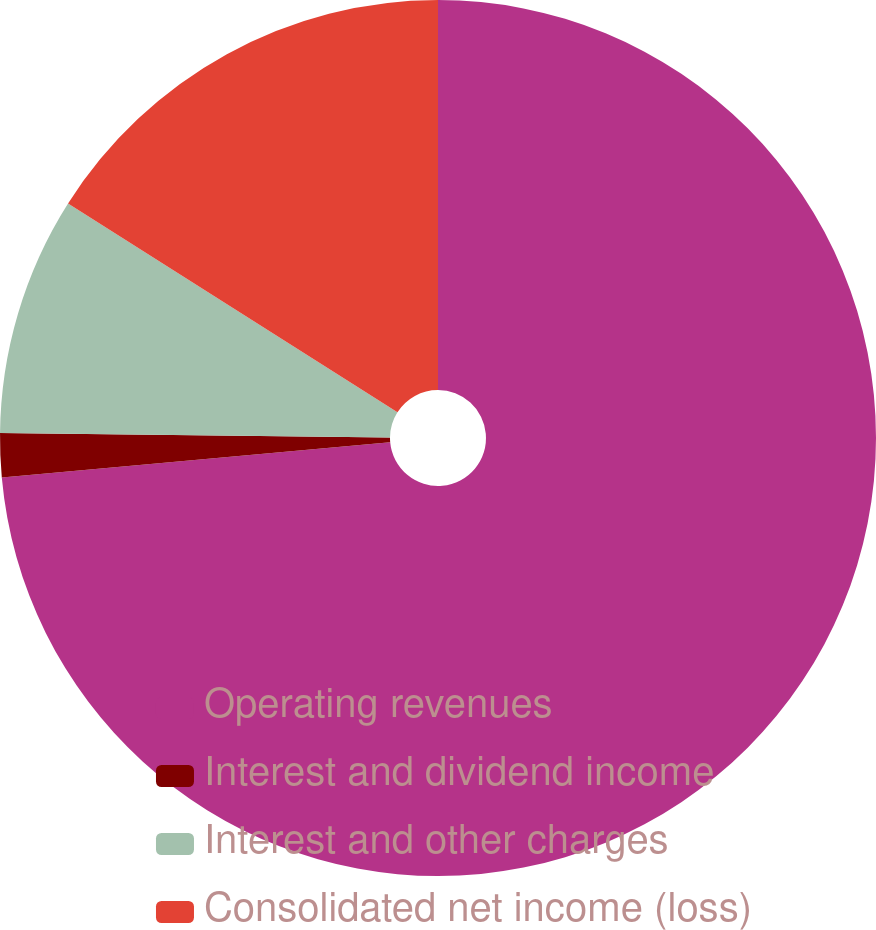<chart> <loc_0><loc_0><loc_500><loc_500><pie_chart><fcel>Operating revenues<fcel>Interest and dividend income<fcel>Interest and other charges<fcel>Consolidated net income (loss)<nl><fcel>73.56%<fcel>1.62%<fcel>8.81%<fcel>16.01%<nl></chart> 